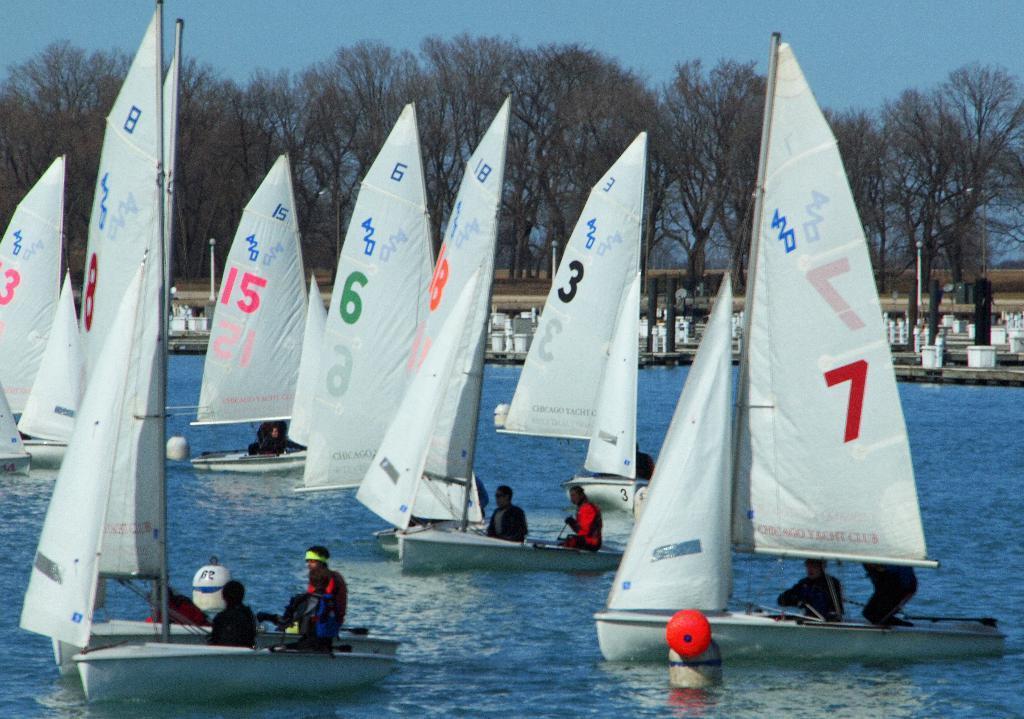Could you give a brief overview of what you see in this image? In the center of the image there are boats in the water. In the background of the image there are trees. At the top of the image there is sky. 